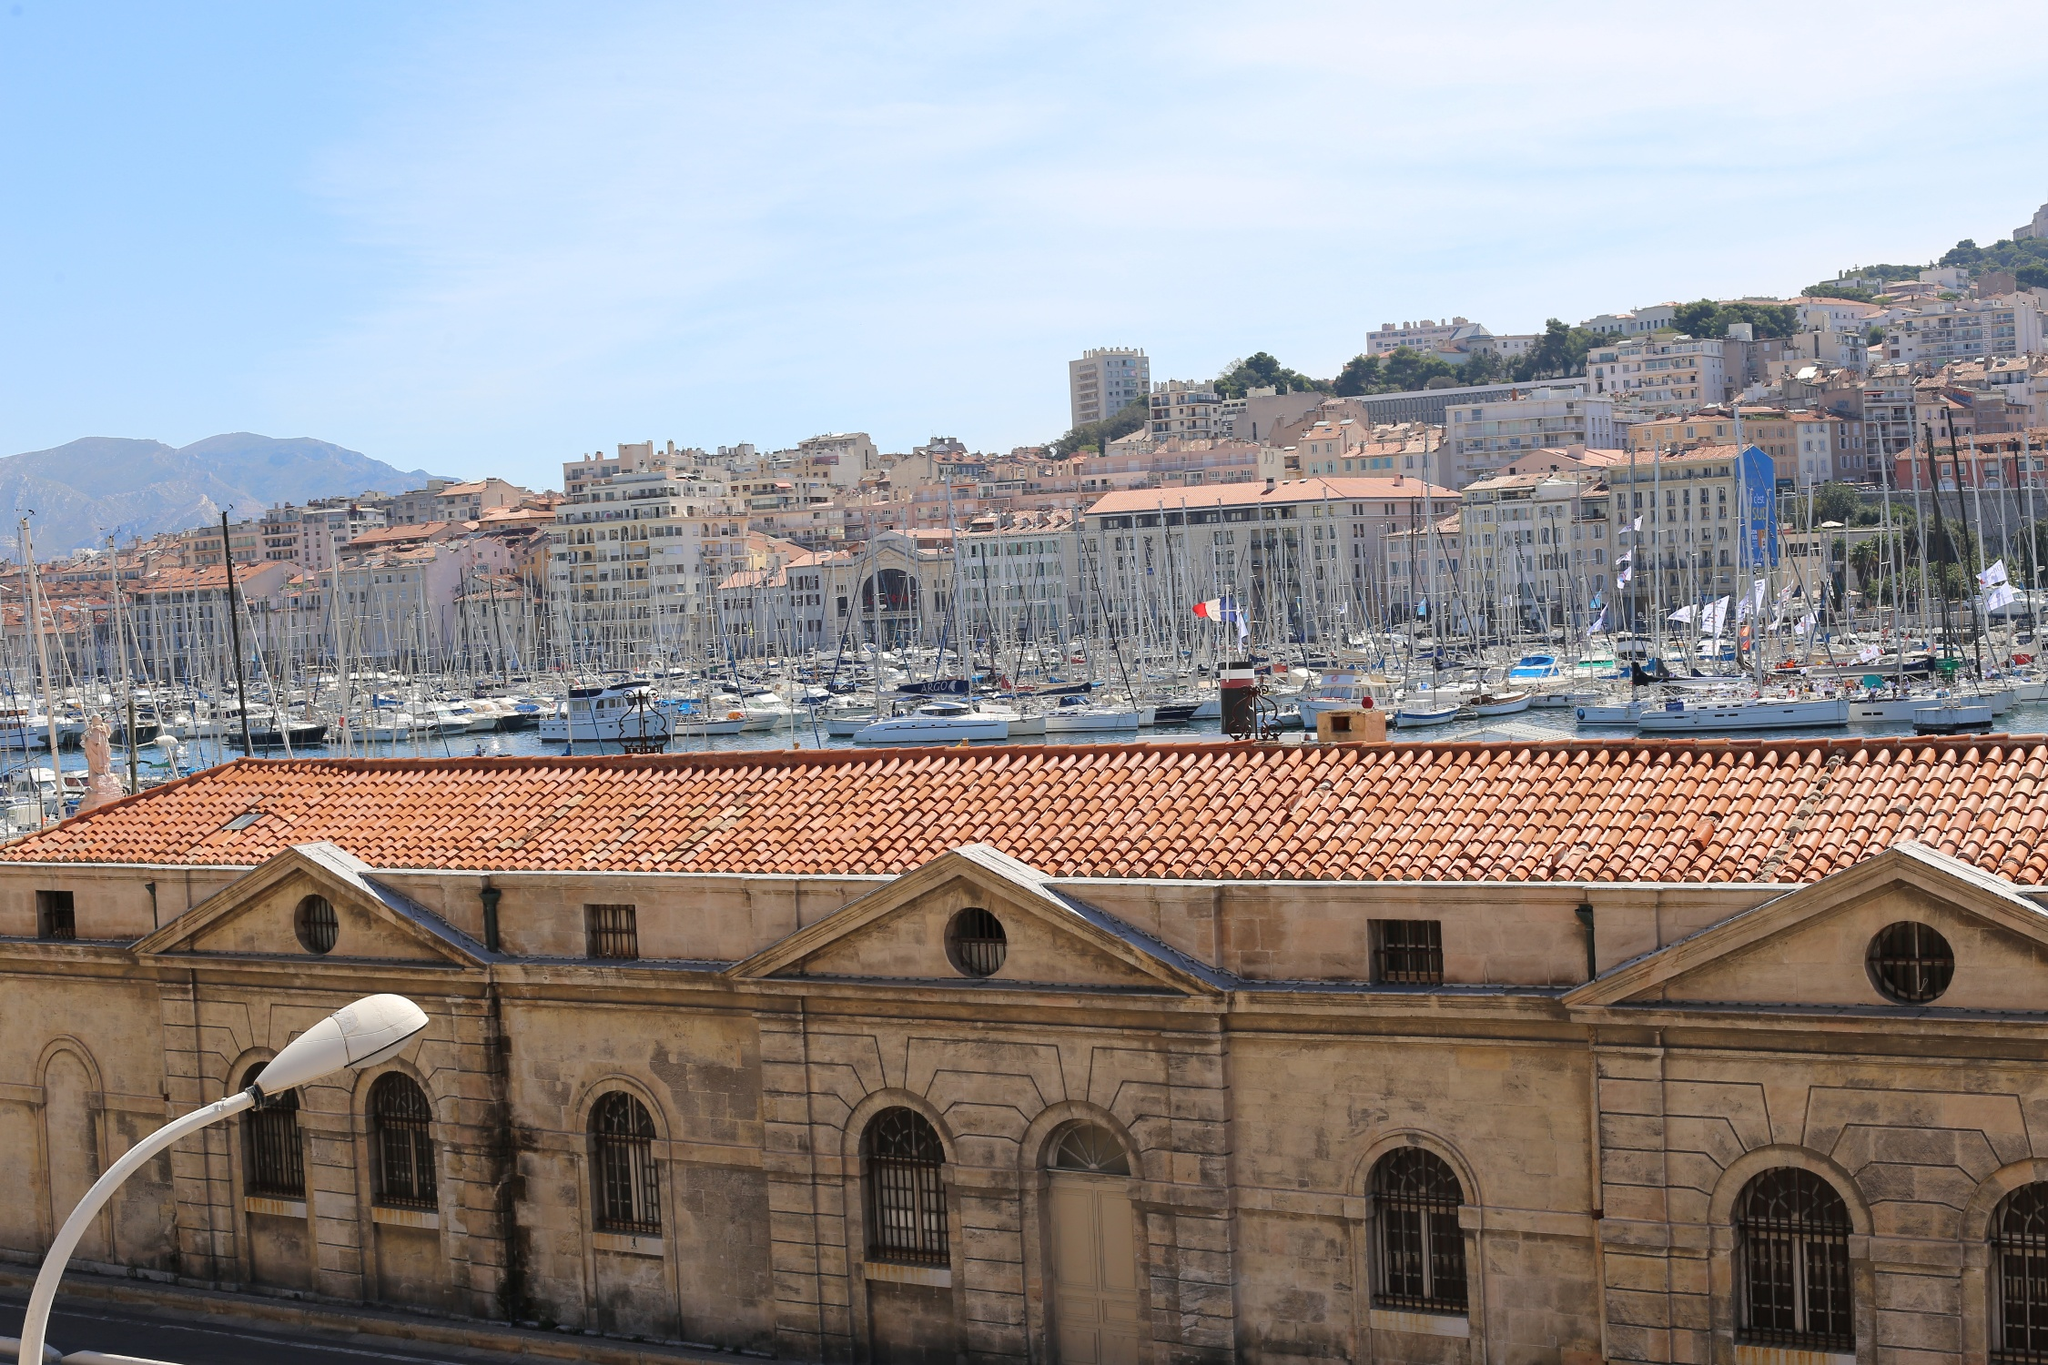If you were to spend an entire day at this location, how would you describe your experience? Spending an entire day at the Old Port of Marseille would be an immersive experience filled with sights, sounds, and flavors. The day would start with a leisurely breakfast at one of the waterfront cafés, where the aroma of freshly brewed coffee blends with the salty sea breeze. Strolling along the port, you'd admire the countless boats bobbing gently against their moorings. A visit to the bustling fish market would offer a glimpse into the local maritime culture and perhaps a taste of some fresh seafood. By midday, the sun would be high, perfect for a boat tour to explore the scenic coastline. As the afternoon progresses, exploring the historical buildings and narrow streets lined with shops and cafés would reveal the rich heritage and charm of Marseille. As evening falls, the port would light up with the golden hues of the setting sun, reflected on the calm waters, creating a magical ambiance. Dinner at a local restaurant with a view of the illuminated port would be the perfect end to a thrilling yet relaxing day. 